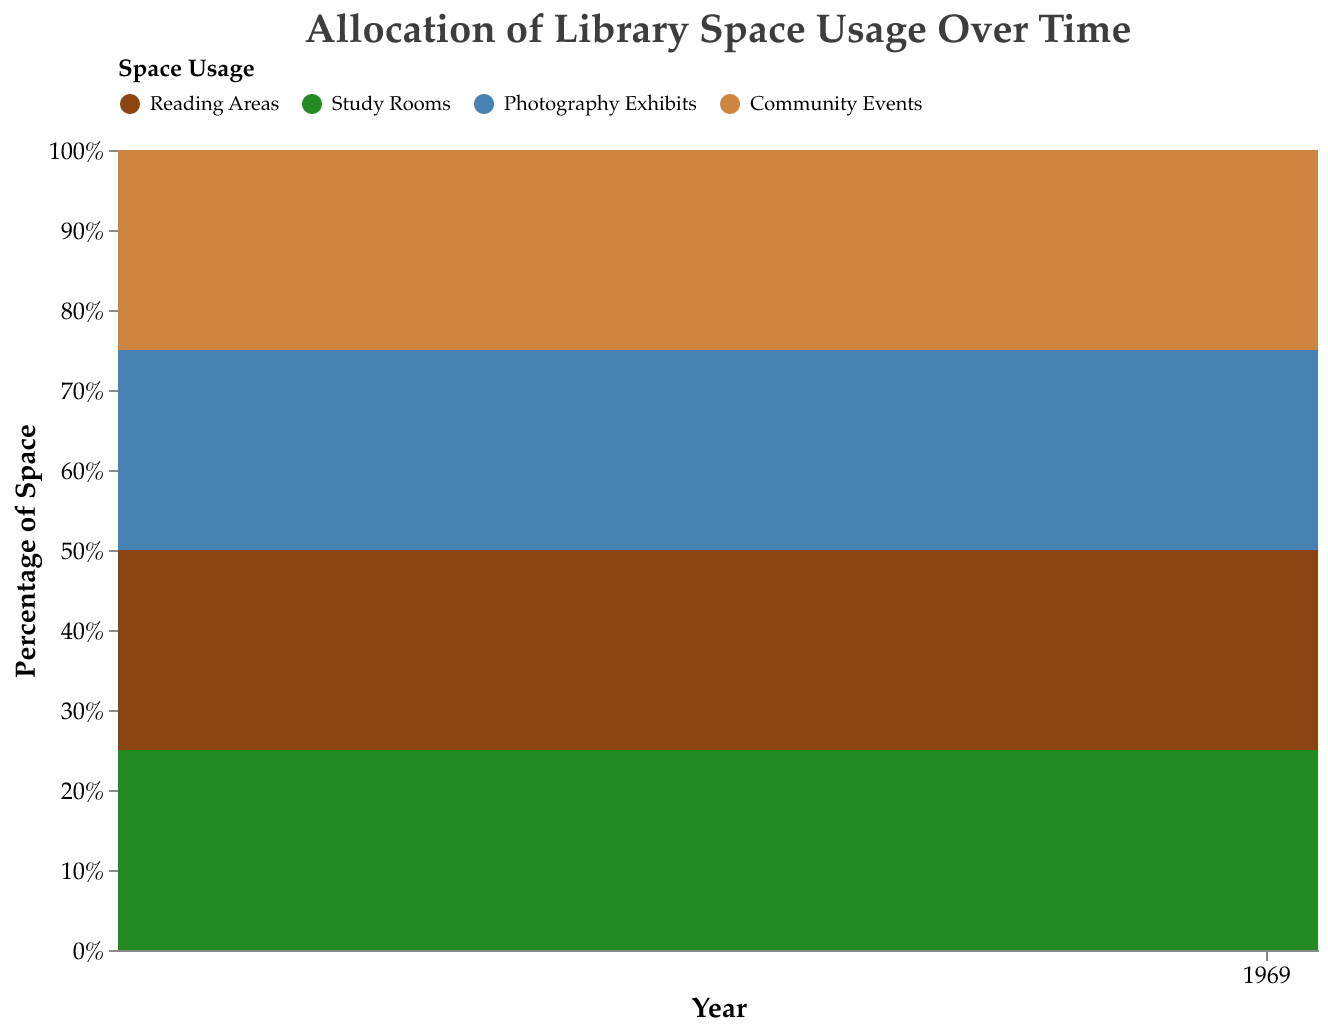What is the title of the figure? The title is displayed at the top of the figure in large font. It is specified as "Allocation of Library Space Usage Over Time."
Answer: Allocation of Library Space Usage Over Time How has the space allocated to Reading Areas changed from 2000 to 2023? Reading Areas start at 50% in 2000 and decrease steadily to 27% in 2023, as seen by the diminishing height of the corresponding area over time.
Answer: Decreased from 50% to 27% Which time period has the highest allocation for Study Rooms? The area for Study Rooms reaches its peak proportion in 2023, indicated by the highest area coverage for this space category in the visualization.
Answer: 2023 Between what years did Photography Exhibits see a noticeable increase in space allocation? The space for Photography Exhibits increases significantly starting around 2005, moving from 13% in 2005 to 23% in 2023, as shown by the rising area for this category.
Answer: 2005 to 2023 What is the combined space allocation for Reading Areas and Community Events in 2010? In 2010, Reading Areas take up 40% and Community Events take up 6%, totaling 46%. The sum of their areas is shown where they align on the y-axis at 2010.
Answer: 46% Compare the space allocated to Reading Areas and Study Rooms in 2012. In 2012, Reading Areas are allocated 38%, while Study Rooms are allocated 39%. The difference can be observed on the y-axis values for these areas in that year.
Answer: Study Rooms have 1% more space than Reading Areas Has the space for Community Events increased or decreased over the given period? The space for Community Events starts at 10% in 2000 and fluctuates mildly, ending at 5% in 2023. This decrease is observed by the reduction in the area dedicated to Community Events over time.
Answer: Decreased What is the trend in the allocation of space for Study Rooms over time? Study Rooms show a steady increase from 30% in 2000 to 45% in both 2022 and 2023, indicated by the expanding area for this category.
Answer: Increasing By how much did the space allocated to Photography Exhibits change between 2010 and 2023? In 2010, Photography Exhibits occupy 16% of the space, and by 2023, they occupy 23%. The change is calculated as 23% - 16% = 7%.
Answer: Increased by 7% What is the smallest space allocation observed for Community Events and in which year? The smallest allocation for Community Events, 4%, is observed in 2022, as indicated by the smallest height of the area for this category that year.
Answer: 4% in 2022 